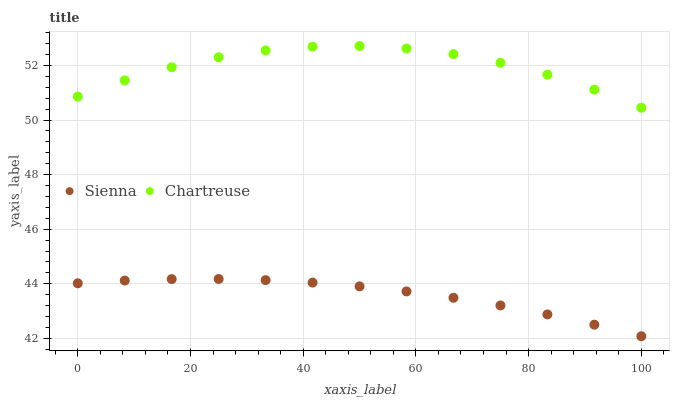Does Sienna have the minimum area under the curve?
Answer yes or no. Yes. Does Chartreuse have the maximum area under the curve?
Answer yes or no. Yes. Does Chartreuse have the minimum area under the curve?
Answer yes or no. No. Is Sienna the smoothest?
Answer yes or no. Yes. Is Chartreuse the roughest?
Answer yes or no. Yes. Is Chartreuse the smoothest?
Answer yes or no. No. Does Sienna have the lowest value?
Answer yes or no. Yes. Does Chartreuse have the lowest value?
Answer yes or no. No. Does Chartreuse have the highest value?
Answer yes or no. Yes. Is Sienna less than Chartreuse?
Answer yes or no. Yes. Is Chartreuse greater than Sienna?
Answer yes or no. Yes. Does Sienna intersect Chartreuse?
Answer yes or no. No. 